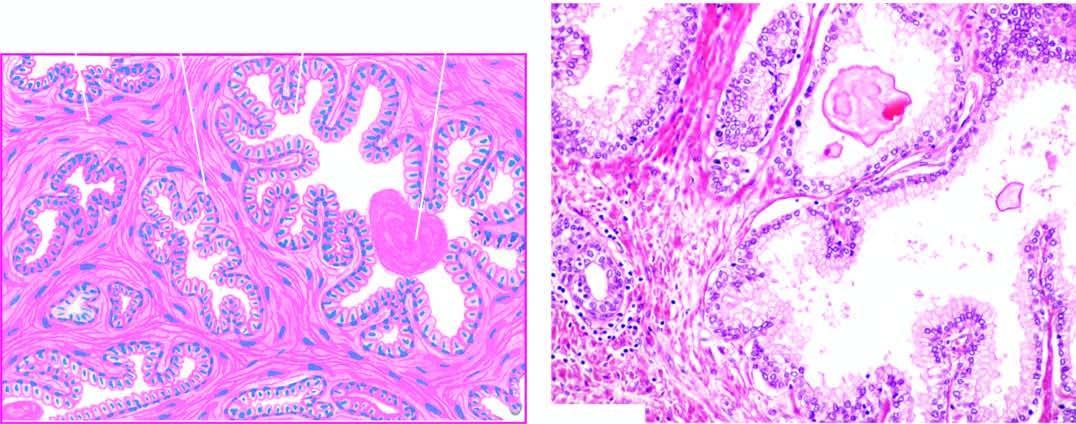there are areas of intra-acinar papillary infoldings lined by how many layers of epithelium with basal polarity of nuclei?
Answer the question using a single word or phrase. Two 